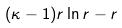<formula> <loc_0><loc_0><loc_500><loc_500>( \kappa - 1 ) r \ln r - r</formula> 